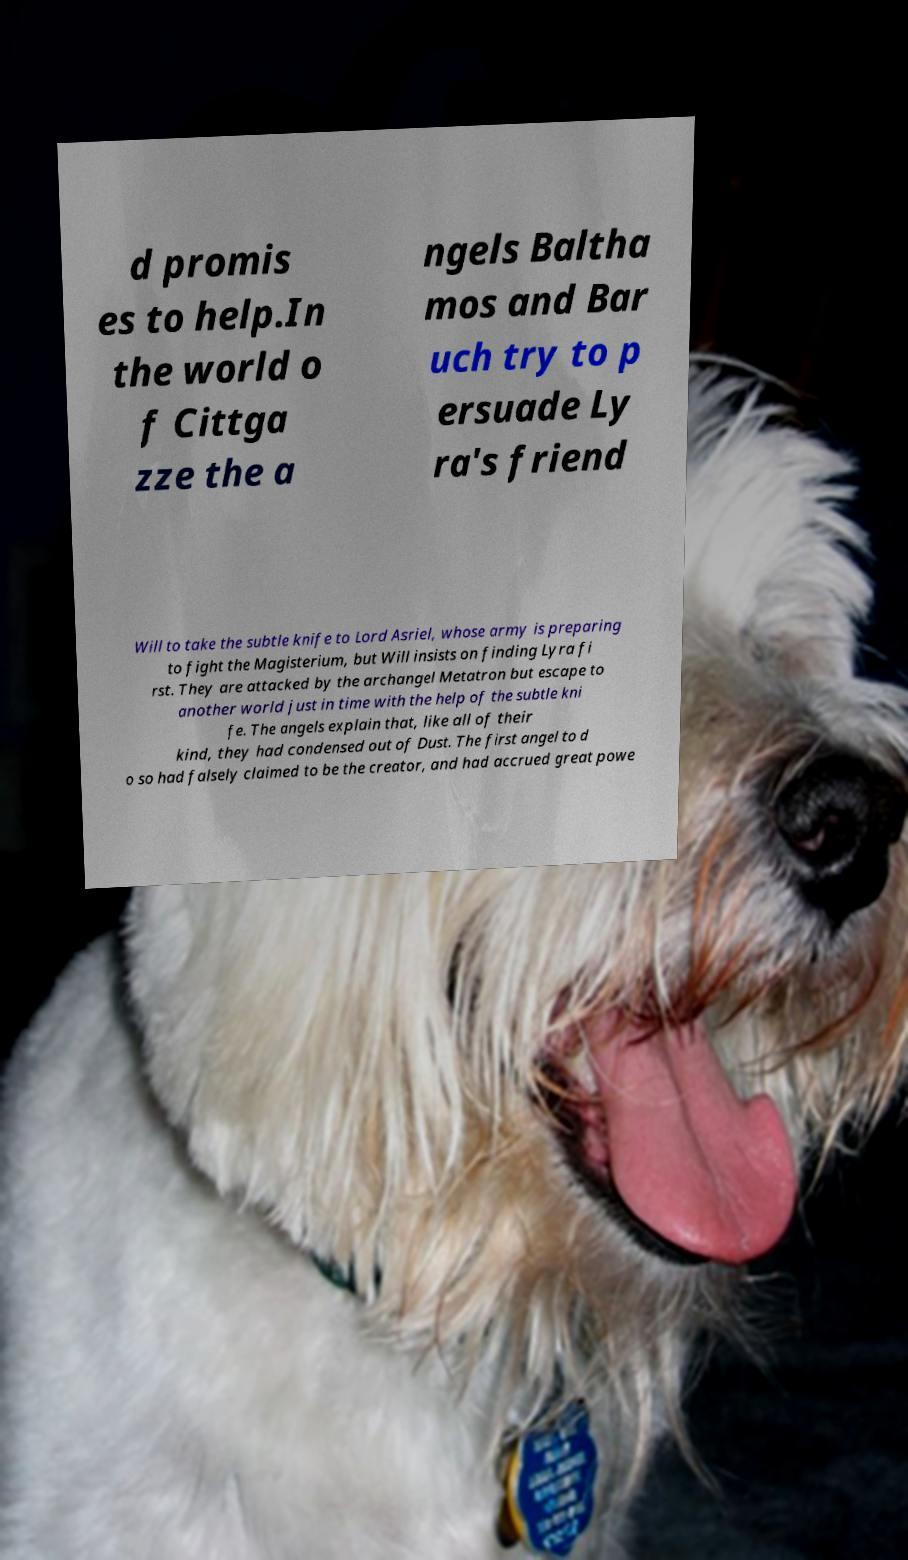Please identify and transcribe the text found in this image. d promis es to help.In the world o f Cittga zze the a ngels Baltha mos and Bar uch try to p ersuade Ly ra's friend Will to take the subtle knife to Lord Asriel, whose army is preparing to fight the Magisterium, but Will insists on finding Lyra fi rst. They are attacked by the archangel Metatron but escape to another world just in time with the help of the subtle kni fe. The angels explain that, like all of their kind, they had condensed out of Dust. The first angel to d o so had falsely claimed to be the creator, and had accrued great powe 